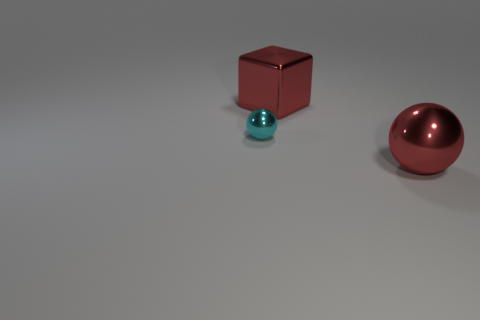What number of brown objects are either tiny metallic spheres or balls?
Make the answer very short. 0. How many big metal objects have the same color as the large shiny block?
Your answer should be very brief. 1. What number of large red metallic balls are behind the metal ball in front of the small cyan metallic object?
Provide a succinct answer. 0. Do the red metal sphere and the red metal cube have the same size?
Your answer should be very brief. Yes. How many tiny cyan objects have the same material as the big cube?
Your answer should be compact. 1. Does the object that is behind the tiny ball have the same shape as the small object?
Ensure brevity in your answer.  No. What shape is the large red thing left of the large red metallic object in front of the metal cube?
Ensure brevity in your answer.  Cube. What color is the large shiny object that is the same shape as the small cyan object?
Give a very brief answer. Red. Is the color of the large shiny cube the same as the shiny ball that is on the right side of the small ball?
Ensure brevity in your answer.  Yes. The shiny thing that is behind the big red metallic ball and on the right side of the tiny cyan object has what shape?
Ensure brevity in your answer.  Cube. 